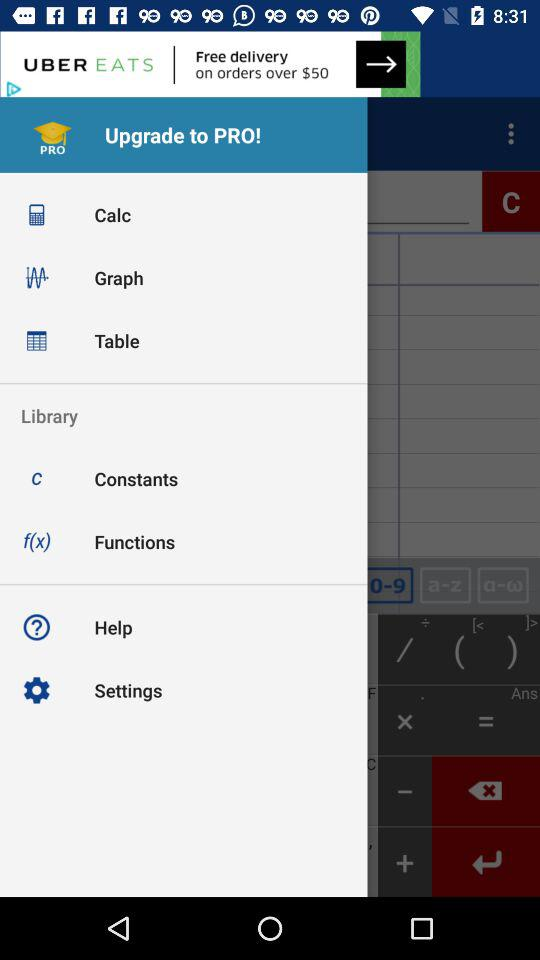What is the name of the application?
When the provided information is insufficient, respond with <no answer>. <no answer> 